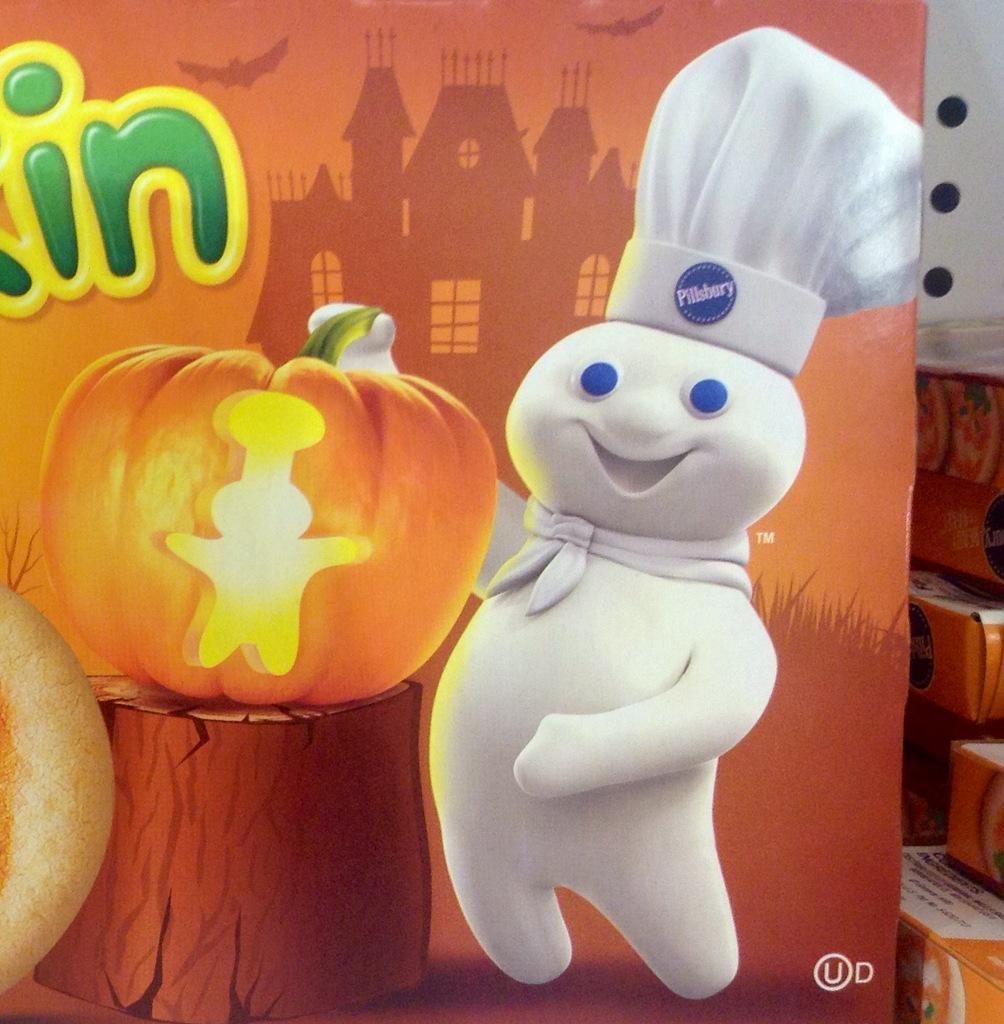Could you give a brief overview of what you see in this image? In this image I can see the cardboard box in orange color and I can also see the toy, pumpkin and something written on the box. In the background I can see few other cardboard boxes. 